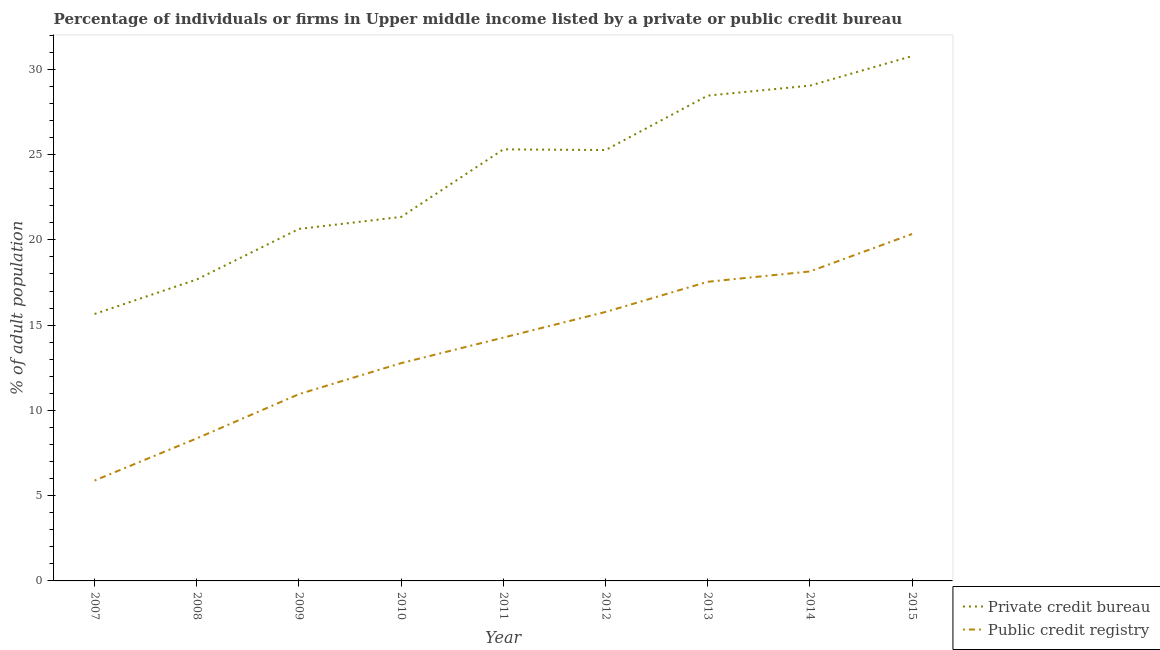Does the line corresponding to percentage of firms listed by public credit bureau intersect with the line corresponding to percentage of firms listed by private credit bureau?
Provide a short and direct response. No. Is the number of lines equal to the number of legend labels?
Offer a very short reply. Yes. What is the percentage of firms listed by private credit bureau in 2007?
Keep it short and to the point. 15.65. Across all years, what is the maximum percentage of firms listed by private credit bureau?
Keep it short and to the point. 30.78. Across all years, what is the minimum percentage of firms listed by private credit bureau?
Offer a terse response. 15.65. In which year was the percentage of firms listed by private credit bureau maximum?
Provide a short and direct response. 2015. What is the total percentage of firms listed by public credit bureau in the graph?
Give a very brief answer. 124.04. What is the difference between the percentage of firms listed by private credit bureau in 2007 and that in 2015?
Provide a short and direct response. -15.12. What is the difference between the percentage of firms listed by public credit bureau in 2012 and the percentage of firms listed by private credit bureau in 2013?
Your answer should be compact. -12.69. What is the average percentage of firms listed by public credit bureau per year?
Give a very brief answer. 13.78. In the year 2007, what is the difference between the percentage of firms listed by private credit bureau and percentage of firms listed by public credit bureau?
Keep it short and to the point. 9.77. In how many years, is the percentage of firms listed by private credit bureau greater than 3 %?
Make the answer very short. 9. What is the ratio of the percentage of firms listed by public credit bureau in 2010 to that in 2013?
Offer a very short reply. 0.73. Is the percentage of firms listed by public credit bureau in 2008 less than that in 2014?
Ensure brevity in your answer.  Yes. What is the difference between the highest and the second highest percentage of firms listed by private credit bureau?
Your response must be concise. 1.73. What is the difference between the highest and the lowest percentage of firms listed by public credit bureau?
Provide a succinct answer. 14.46. Does the percentage of firms listed by private credit bureau monotonically increase over the years?
Provide a succinct answer. No. Is the percentage of firms listed by private credit bureau strictly greater than the percentage of firms listed by public credit bureau over the years?
Your response must be concise. Yes. Is the percentage of firms listed by public credit bureau strictly less than the percentage of firms listed by private credit bureau over the years?
Ensure brevity in your answer.  Yes. How many lines are there?
Your answer should be compact. 2. What is the difference between two consecutive major ticks on the Y-axis?
Offer a terse response. 5. Does the graph contain grids?
Keep it short and to the point. No. How are the legend labels stacked?
Keep it short and to the point. Vertical. What is the title of the graph?
Your answer should be very brief. Percentage of individuals or firms in Upper middle income listed by a private or public credit bureau. Does "Lower secondary education" appear as one of the legend labels in the graph?
Your answer should be compact. No. What is the label or title of the X-axis?
Provide a succinct answer. Year. What is the label or title of the Y-axis?
Ensure brevity in your answer.  % of adult population. What is the % of adult population in Private credit bureau in 2007?
Your answer should be very brief. 15.65. What is the % of adult population of Public credit registry in 2007?
Make the answer very short. 5.89. What is the % of adult population in Private credit bureau in 2008?
Give a very brief answer. 17.68. What is the % of adult population in Public credit registry in 2008?
Offer a very short reply. 8.36. What is the % of adult population of Private credit bureau in 2009?
Keep it short and to the point. 20.64. What is the % of adult population of Public credit registry in 2009?
Give a very brief answer. 10.95. What is the % of adult population in Private credit bureau in 2010?
Make the answer very short. 21.34. What is the % of adult population in Public credit registry in 2010?
Your answer should be compact. 12.77. What is the % of adult population of Private credit bureau in 2011?
Give a very brief answer. 25.31. What is the % of adult population in Public credit registry in 2011?
Ensure brevity in your answer.  14.27. What is the % of adult population of Private credit bureau in 2012?
Offer a very short reply. 25.27. What is the % of adult population in Public credit registry in 2012?
Your response must be concise. 15.77. What is the % of adult population in Private credit bureau in 2013?
Make the answer very short. 28.46. What is the % of adult population of Public credit registry in 2013?
Give a very brief answer. 17.54. What is the % of adult population of Private credit bureau in 2014?
Make the answer very short. 29.04. What is the % of adult population in Public credit registry in 2014?
Provide a short and direct response. 18.15. What is the % of adult population of Private credit bureau in 2015?
Your response must be concise. 30.78. What is the % of adult population in Public credit registry in 2015?
Provide a short and direct response. 20.34. Across all years, what is the maximum % of adult population of Private credit bureau?
Provide a short and direct response. 30.78. Across all years, what is the maximum % of adult population in Public credit registry?
Keep it short and to the point. 20.34. Across all years, what is the minimum % of adult population in Private credit bureau?
Provide a short and direct response. 15.65. Across all years, what is the minimum % of adult population of Public credit registry?
Make the answer very short. 5.89. What is the total % of adult population of Private credit bureau in the graph?
Provide a succinct answer. 214.16. What is the total % of adult population of Public credit registry in the graph?
Offer a very short reply. 124.04. What is the difference between the % of adult population in Private credit bureau in 2007 and that in 2008?
Your response must be concise. -2.02. What is the difference between the % of adult population in Public credit registry in 2007 and that in 2008?
Provide a short and direct response. -2.47. What is the difference between the % of adult population of Private credit bureau in 2007 and that in 2009?
Offer a very short reply. -4.99. What is the difference between the % of adult population in Public credit registry in 2007 and that in 2009?
Your answer should be very brief. -5.07. What is the difference between the % of adult population of Private credit bureau in 2007 and that in 2010?
Provide a short and direct response. -5.69. What is the difference between the % of adult population of Public credit registry in 2007 and that in 2010?
Provide a short and direct response. -6.88. What is the difference between the % of adult population in Private credit bureau in 2007 and that in 2011?
Provide a short and direct response. -9.65. What is the difference between the % of adult population of Public credit registry in 2007 and that in 2011?
Keep it short and to the point. -8.38. What is the difference between the % of adult population in Private credit bureau in 2007 and that in 2012?
Keep it short and to the point. -9.61. What is the difference between the % of adult population in Public credit registry in 2007 and that in 2012?
Keep it short and to the point. -9.89. What is the difference between the % of adult population in Private credit bureau in 2007 and that in 2013?
Ensure brevity in your answer.  -12.81. What is the difference between the % of adult population of Public credit registry in 2007 and that in 2013?
Provide a succinct answer. -11.65. What is the difference between the % of adult population of Private credit bureau in 2007 and that in 2014?
Keep it short and to the point. -13.39. What is the difference between the % of adult population of Public credit registry in 2007 and that in 2014?
Offer a very short reply. -12.26. What is the difference between the % of adult population in Private credit bureau in 2007 and that in 2015?
Give a very brief answer. -15.12. What is the difference between the % of adult population of Public credit registry in 2007 and that in 2015?
Your answer should be compact. -14.46. What is the difference between the % of adult population of Private credit bureau in 2008 and that in 2009?
Make the answer very short. -2.96. What is the difference between the % of adult population in Public credit registry in 2008 and that in 2009?
Provide a succinct answer. -2.59. What is the difference between the % of adult population in Private credit bureau in 2008 and that in 2010?
Provide a short and direct response. -3.67. What is the difference between the % of adult population in Public credit registry in 2008 and that in 2010?
Give a very brief answer. -4.41. What is the difference between the % of adult population of Private credit bureau in 2008 and that in 2011?
Your response must be concise. -7.63. What is the difference between the % of adult population in Public credit registry in 2008 and that in 2011?
Your answer should be very brief. -5.91. What is the difference between the % of adult population in Private credit bureau in 2008 and that in 2012?
Make the answer very short. -7.59. What is the difference between the % of adult population in Public credit registry in 2008 and that in 2012?
Keep it short and to the point. -7.41. What is the difference between the % of adult population in Private credit bureau in 2008 and that in 2013?
Give a very brief answer. -10.78. What is the difference between the % of adult population of Public credit registry in 2008 and that in 2013?
Ensure brevity in your answer.  -9.18. What is the difference between the % of adult population in Private credit bureau in 2008 and that in 2014?
Give a very brief answer. -11.37. What is the difference between the % of adult population of Public credit registry in 2008 and that in 2014?
Make the answer very short. -9.79. What is the difference between the % of adult population of Private credit bureau in 2008 and that in 2015?
Provide a succinct answer. -13.1. What is the difference between the % of adult population of Public credit registry in 2008 and that in 2015?
Make the answer very short. -11.98. What is the difference between the % of adult population in Private credit bureau in 2009 and that in 2010?
Provide a short and direct response. -0.7. What is the difference between the % of adult population in Public credit registry in 2009 and that in 2010?
Ensure brevity in your answer.  -1.82. What is the difference between the % of adult population in Private credit bureau in 2009 and that in 2011?
Offer a terse response. -4.67. What is the difference between the % of adult population of Public credit registry in 2009 and that in 2011?
Make the answer very short. -3.32. What is the difference between the % of adult population of Private credit bureau in 2009 and that in 2012?
Offer a terse response. -4.63. What is the difference between the % of adult population of Public credit registry in 2009 and that in 2012?
Provide a succinct answer. -4.82. What is the difference between the % of adult population of Private credit bureau in 2009 and that in 2013?
Make the answer very short. -7.82. What is the difference between the % of adult population in Public credit registry in 2009 and that in 2013?
Offer a very short reply. -6.59. What is the difference between the % of adult population in Private credit bureau in 2009 and that in 2014?
Keep it short and to the point. -8.4. What is the difference between the % of adult population in Public credit registry in 2009 and that in 2014?
Provide a succinct answer. -7.19. What is the difference between the % of adult population in Private credit bureau in 2009 and that in 2015?
Provide a succinct answer. -10.14. What is the difference between the % of adult population of Public credit registry in 2009 and that in 2015?
Provide a short and direct response. -9.39. What is the difference between the % of adult population of Private credit bureau in 2010 and that in 2011?
Provide a succinct answer. -3.96. What is the difference between the % of adult population in Public credit registry in 2010 and that in 2011?
Keep it short and to the point. -1.5. What is the difference between the % of adult population in Private credit bureau in 2010 and that in 2012?
Make the answer very short. -3.92. What is the difference between the % of adult population of Public credit registry in 2010 and that in 2012?
Keep it short and to the point. -3. What is the difference between the % of adult population of Private credit bureau in 2010 and that in 2013?
Give a very brief answer. -7.11. What is the difference between the % of adult population of Public credit registry in 2010 and that in 2013?
Provide a succinct answer. -4.77. What is the difference between the % of adult population of Private credit bureau in 2010 and that in 2014?
Ensure brevity in your answer.  -7.7. What is the difference between the % of adult population of Public credit registry in 2010 and that in 2014?
Your response must be concise. -5.38. What is the difference between the % of adult population of Private credit bureau in 2010 and that in 2015?
Your response must be concise. -9.43. What is the difference between the % of adult population in Public credit registry in 2010 and that in 2015?
Offer a very short reply. -7.57. What is the difference between the % of adult population in Private credit bureau in 2011 and that in 2012?
Give a very brief answer. 0.04. What is the difference between the % of adult population in Public credit registry in 2011 and that in 2012?
Provide a short and direct response. -1.5. What is the difference between the % of adult population of Private credit bureau in 2011 and that in 2013?
Provide a succinct answer. -3.15. What is the difference between the % of adult population in Public credit registry in 2011 and that in 2013?
Your answer should be compact. -3.27. What is the difference between the % of adult population of Private credit bureau in 2011 and that in 2014?
Ensure brevity in your answer.  -3.74. What is the difference between the % of adult population of Public credit registry in 2011 and that in 2014?
Make the answer very short. -3.88. What is the difference between the % of adult population in Private credit bureau in 2011 and that in 2015?
Provide a short and direct response. -5.47. What is the difference between the % of adult population in Public credit registry in 2011 and that in 2015?
Offer a very short reply. -6.07. What is the difference between the % of adult population in Private credit bureau in 2012 and that in 2013?
Offer a terse response. -3.19. What is the difference between the % of adult population of Public credit registry in 2012 and that in 2013?
Ensure brevity in your answer.  -1.77. What is the difference between the % of adult population in Private credit bureau in 2012 and that in 2014?
Your answer should be very brief. -3.78. What is the difference between the % of adult population of Public credit registry in 2012 and that in 2014?
Offer a very short reply. -2.38. What is the difference between the % of adult population in Private credit bureau in 2012 and that in 2015?
Ensure brevity in your answer.  -5.51. What is the difference between the % of adult population of Public credit registry in 2012 and that in 2015?
Your answer should be compact. -4.57. What is the difference between the % of adult population in Private credit bureau in 2013 and that in 2014?
Offer a very short reply. -0.58. What is the difference between the % of adult population in Public credit registry in 2013 and that in 2014?
Your response must be concise. -0.61. What is the difference between the % of adult population in Private credit bureau in 2013 and that in 2015?
Give a very brief answer. -2.32. What is the difference between the % of adult population of Public credit registry in 2013 and that in 2015?
Give a very brief answer. -2.8. What is the difference between the % of adult population in Private credit bureau in 2014 and that in 2015?
Give a very brief answer. -1.73. What is the difference between the % of adult population of Public credit registry in 2014 and that in 2015?
Provide a short and direct response. -2.2. What is the difference between the % of adult population in Private credit bureau in 2007 and the % of adult population in Public credit registry in 2008?
Offer a very short reply. 7.29. What is the difference between the % of adult population in Private credit bureau in 2007 and the % of adult population in Public credit registry in 2010?
Your response must be concise. 2.88. What is the difference between the % of adult population in Private credit bureau in 2007 and the % of adult population in Public credit registry in 2011?
Your answer should be compact. 1.38. What is the difference between the % of adult population in Private credit bureau in 2007 and the % of adult population in Public credit registry in 2012?
Give a very brief answer. -0.12. What is the difference between the % of adult population of Private credit bureau in 2007 and the % of adult population of Public credit registry in 2013?
Make the answer very short. -1.89. What is the difference between the % of adult population in Private credit bureau in 2007 and the % of adult population in Public credit registry in 2014?
Make the answer very short. -2.49. What is the difference between the % of adult population of Private credit bureau in 2007 and the % of adult population of Public credit registry in 2015?
Your answer should be compact. -4.69. What is the difference between the % of adult population in Private credit bureau in 2008 and the % of adult population in Public credit registry in 2009?
Keep it short and to the point. 6.72. What is the difference between the % of adult population in Private credit bureau in 2008 and the % of adult population in Public credit registry in 2010?
Your answer should be compact. 4.91. What is the difference between the % of adult population in Private credit bureau in 2008 and the % of adult population in Public credit registry in 2011?
Offer a very short reply. 3.41. What is the difference between the % of adult population in Private credit bureau in 2008 and the % of adult population in Public credit registry in 2012?
Provide a short and direct response. 1.91. What is the difference between the % of adult population of Private credit bureau in 2008 and the % of adult population of Public credit registry in 2013?
Your answer should be very brief. 0.14. What is the difference between the % of adult population in Private credit bureau in 2008 and the % of adult population in Public credit registry in 2014?
Keep it short and to the point. -0.47. What is the difference between the % of adult population in Private credit bureau in 2008 and the % of adult population in Public credit registry in 2015?
Your answer should be very brief. -2.67. What is the difference between the % of adult population of Private credit bureau in 2009 and the % of adult population of Public credit registry in 2010?
Your answer should be very brief. 7.87. What is the difference between the % of adult population in Private credit bureau in 2009 and the % of adult population in Public credit registry in 2011?
Offer a very short reply. 6.37. What is the difference between the % of adult population of Private credit bureau in 2009 and the % of adult population of Public credit registry in 2012?
Offer a very short reply. 4.87. What is the difference between the % of adult population of Private credit bureau in 2009 and the % of adult population of Public credit registry in 2013?
Offer a very short reply. 3.1. What is the difference between the % of adult population in Private credit bureau in 2009 and the % of adult population in Public credit registry in 2014?
Provide a succinct answer. 2.49. What is the difference between the % of adult population in Private credit bureau in 2009 and the % of adult population in Public credit registry in 2015?
Your answer should be compact. 0.3. What is the difference between the % of adult population of Private credit bureau in 2010 and the % of adult population of Public credit registry in 2011?
Your answer should be very brief. 7.08. What is the difference between the % of adult population in Private credit bureau in 2010 and the % of adult population in Public credit registry in 2012?
Ensure brevity in your answer.  5.57. What is the difference between the % of adult population of Private credit bureau in 2010 and the % of adult population of Public credit registry in 2013?
Your answer should be very brief. 3.8. What is the difference between the % of adult population of Private credit bureau in 2010 and the % of adult population of Public credit registry in 2014?
Ensure brevity in your answer.  3.2. What is the difference between the % of adult population in Private credit bureau in 2010 and the % of adult population in Public credit registry in 2015?
Your answer should be compact. 1. What is the difference between the % of adult population of Private credit bureau in 2011 and the % of adult population of Public credit registry in 2012?
Your answer should be very brief. 9.53. What is the difference between the % of adult population in Private credit bureau in 2011 and the % of adult population in Public credit registry in 2013?
Make the answer very short. 7.77. What is the difference between the % of adult population in Private credit bureau in 2011 and the % of adult population in Public credit registry in 2014?
Give a very brief answer. 7.16. What is the difference between the % of adult population of Private credit bureau in 2011 and the % of adult population of Public credit registry in 2015?
Keep it short and to the point. 4.96. What is the difference between the % of adult population of Private credit bureau in 2012 and the % of adult population of Public credit registry in 2013?
Give a very brief answer. 7.72. What is the difference between the % of adult population in Private credit bureau in 2012 and the % of adult population in Public credit registry in 2014?
Ensure brevity in your answer.  7.12. What is the difference between the % of adult population in Private credit bureau in 2012 and the % of adult population in Public credit registry in 2015?
Provide a short and direct response. 4.92. What is the difference between the % of adult population in Private credit bureau in 2013 and the % of adult population in Public credit registry in 2014?
Give a very brief answer. 10.31. What is the difference between the % of adult population in Private credit bureau in 2013 and the % of adult population in Public credit registry in 2015?
Your answer should be compact. 8.12. What is the average % of adult population of Private credit bureau per year?
Keep it short and to the point. 23.8. What is the average % of adult population in Public credit registry per year?
Provide a short and direct response. 13.78. In the year 2007, what is the difference between the % of adult population in Private credit bureau and % of adult population in Public credit registry?
Ensure brevity in your answer.  9.77. In the year 2008, what is the difference between the % of adult population of Private credit bureau and % of adult population of Public credit registry?
Ensure brevity in your answer.  9.32. In the year 2009, what is the difference between the % of adult population in Private credit bureau and % of adult population in Public credit registry?
Offer a very short reply. 9.69. In the year 2010, what is the difference between the % of adult population in Private credit bureau and % of adult population in Public credit registry?
Keep it short and to the point. 8.57. In the year 2011, what is the difference between the % of adult population in Private credit bureau and % of adult population in Public credit registry?
Your answer should be compact. 11.04. In the year 2012, what is the difference between the % of adult population of Private credit bureau and % of adult population of Public credit registry?
Your answer should be very brief. 9.49. In the year 2013, what is the difference between the % of adult population in Private credit bureau and % of adult population in Public credit registry?
Provide a succinct answer. 10.92. In the year 2014, what is the difference between the % of adult population in Private credit bureau and % of adult population in Public credit registry?
Your answer should be compact. 10.9. In the year 2015, what is the difference between the % of adult population in Private credit bureau and % of adult population in Public credit registry?
Your response must be concise. 10.43. What is the ratio of the % of adult population in Private credit bureau in 2007 to that in 2008?
Offer a very short reply. 0.89. What is the ratio of the % of adult population in Public credit registry in 2007 to that in 2008?
Offer a very short reply. 0.7. What is the ratio of the % of adult population of Private credit bureau in 2007 to that in 2009?
Give a very brief answer. 0.76. What is the ratio of the % of adult population of Public credit registry in 2007 to that in 2009?
Your answer should be very brief. 0.54. What is the ratio of the % of adult population of Private credit bureau in 2007 to that in 2010?
Offer a very short reply. 0.73. What is the ratio of the % of adult population of Public credit registry in 2007 to that in 2010?
Offer a very short reply. 0.46. What is the ratio of the % of adult population of Private credit bureau in 2007 to that in 2011?
Ensure brevity in your answer.  0.62. What is the ratio of the % of adult population of Public credit registry in 2007 to that in 2011?
Your answer should be compact. 0.41. What is the ratio of the % of adult population of Private credit bureau in 2007 to that in 2012?
Make the answer very short. 0.62. What is the ratio of the % of adult population in Public credit registry in 2007 to that in 2012?
Keep it short and to the point. 0.37. What is the ratio of the % of adult population of Private credit bureau in 2007 to that in 2013?
Your answer should be compact. 0.55. What is the ratio of the % of adult population in Public credit registry in 2007 to that in 2013?
Ensure brevity in your answer.  0.34. What is the ratio of the % of adult population of Private credit bureau in 2007 to that in 2014?
Give a very brief answer. 0.54. What is the ratio of the % of adult population of Public credit registry in 2007 to that in 2014?
Make the answer very short. 0.32. What is the ratio of the % of adult population of Private credit bureau in 2007 to that in 2015?
Provide a succinct answer. 0.51. What is the ratio of the % of adult population of Public credit registry in 2007 to that in 2015?
Give a very brief answer. 0.29. What is the ratio of the % of adult population in Private credit bureau in 2008 to that in 2009?
Your response must be concise. 0.86. What is the ratio of the % of adult population of Public credit registry in 2008 to that in 2009?
Keep it short and to the point. 0.76. What is the ratio of the % of adult population of Private credit bureau in 2008 to that in 2010?
Your answer should be very brief. 0.83. What is the ratio of the % of adult population in Public credit registry in 2008 to that in 2010?
Ensure brevity in your answer.  0.65. What is the ratio of the % of adult population of Private credit bureau in 2008 to that in 2011?
Ensure brevity in your answer.  0.7. What is the ratio of the % of adult population of Public credit registry in 2008 to that in 2011?
Provide a succinct answer. 0.59. What is the ratio of the % of adult population of Private credit bureau in 2008 to that in 2012?
Keep it short and to the point. 0.7. What is the ratio of the % of adult population of Public credit registry in 2008 to that in 2012?
Your response must be concise. 0.53. What is the ratio of the % of adult population in Private credit bureau in 2008 to that in 2013?
Ensure brevity in your answer.  0.62. What is the ratio of the % of adult population of Public credit registry in 2008 to that in 2013?
Give a very brief answer. 0.48. What is the ratio of the % of adult population of Private credit bureau in 2008 to that in 2014?
Your response must be concise. 0.61. What is the ratio of the % of adult population in Public credit registry in 2008 to that in 2014?
Provide a succinct answer. 0.46. What is the ratio of the % of adult population in Private credit bureau in 2008 to that in 2015?
Your answer should be very brief. 0.57. What is the ratio of the % of adult population in Public credit registry in 2008 to that in 2015?
Ensure brevity in your answer.  0.41. What is the ratio of the % of adult population in Public credit registry in 2009 to that in 2010?
Your response must be concise. 0.86. What is the ratio of the % of adult population of Private credit bureau in 2009 to that in 2011?
Make the answer very short. 0.82. What is the ratio of the % of adult population in Public credit registry in 2009 to that in 2011?
Provide a succinct answer. 0.77. What is the ratio of the % of adult population in Private credit bureau in 2009 to that in 2012?
Keep it short and to the point. 0.82. What is the ratio of the % of adult population of Public credit registry in 2009 to that in 2012?
Ensure brevity in your answer.  0.69. What is the ratio of the % of adult population of Private credit bureau in 2009 to that in 2013?
Offer a terse response. 0.73. What is the ratio of the % of adult population of Public credit registry in 2009 to that in 2013?
Ensure brevity in your answer.  0.62. What is the ratio of the % of adult population of Private credit bureau in 2009 to that in 2014?
Provide a succinct answer. 0.71. What is the ratio of the % of adult population in Public credit registry in 2009 to that in 2014?
Offer a terse response. 0.6. What is the ratio of the % of adult population in Private credit bureau in 2009 to that in 2015?
Give a very brief answer. 0.67. What is the ratio of the % of adult population in Public credit registry in 2009 to that in 2015?
Your answer should be very brief. 0.54. What is the ratio of the % of adult population in Private credit bureau in 2010 to that in 2011?
Offer a terse response. 0.84. What is the ratio of the % of adult population in Public credit registry in 2010 to that in 2011?
Make the answer very short. 0.9. What is the ratio of the % of adult population of Private credit bureau in 2010 to that in 2012?
Ensure brevity in your answer.  0.84. What is the ratio of the % of adult population in Public credit registry in 2010 to that in 2012?
Your response must be concise. 0.81. What is the ratio of the % of adult population of Private credit bureau in 2010 to that in 2013?
Offer a terse response. 0.75. What is the ratio of the % of adult population in Public credit registry in 2010 to that in 2013?
Your response must be concise. 0.73. What is the ratio of the % of adult population in Private credit bureau in 2010 to that in 2014?
Make the answer very short. 0.73. What is the ratio of the % of adult population in Public credit registry in 2010 to that in 2014?
Offer a very short reply. 0.7. What is the ratio of the % of adult population of Private credit bureau in 2010 to that in 2015?
Your answer should be compact. 0.69. What is the ratio of the % of adult population of Public credit registry in 2010 to that in 2015?
Offer a terse response. 0.63. What is the ratio of the % of adult population in Public credit registry in 2011 to that in 2012?
Keep it short and to the point. 0.9. What is the ratio of the % of adult population of Private credit bureau in 2011 to that in 2013?
Ensure brevity in your answer.  0.89. What is the ratio of the % of adult population of Public credit registry in 2011 to that in 2013?
Provide a succinct answer. 0.81. What is the ratio of the % of adult population of Private credit bureau in 2011 to that in 2014?
Your answer should be very brief. 0.87. What is the ratio of the % of adult population in Public credit registry in 2011 to that in 2014?
Your answer should be very brief. 0.79. What is the ratio of the % of adult population of Private credit bureau in 2011 to that in 2015?
Provide a short and direct response. 0.82. What is the ratio of the % of adult population in Public credit registry in 2011 to that in 2015?
Your response must be concise. 0.7. What is the ratio of the % of adult population in Private credit bureau in 2012 to that in 2013?
Keep it short and to the point. 0.89. What is the ratio of the % of adult population in Public credit registry in 2012 to that in 2013?
Offer a very short reply. 0.9. What is the ratio of the % of adult population in Private credit bureau in 2012 to that in 2014?
Your answer should be very brief. 0.87. What is the ratio of the % of adult population of Public credit registry in 2012 to that in 2014?
Provide a short and direct response. 0.87. What is the ratio of the % of adult population in Private credit bureau in 2012 to that in 2015?
Ensure brevity in your answer.  0.82. What is the ratio of the % of adult population in Public credit registry in 2012 to that in 2015?
Provide a succinct answer. 0.78. What is the ratio of the % of adult population in Private credit bureau in 2013 to that in 2014?
Offer a very short reply. 0.98. What is the ratio of the % of adult population in Public credit registry in 2013 to that in 2014?
Provide a short and direct response. 0.97. What is the ratio of the % of adult population of Private credit bureau in 2013 to that in 2015?
Your answer should be very brief. 0.92. What is the ratio of the % of adult population in Public credit registry in 2013 to that in 2015?
Offer a terse response. 0.86. What is the ratio of the % of adult population of Private credit bureau in 2014 to that in 2015?
Offer a terse response. 0.94. What is the ratio of the % of adult population of Public credit registry in 2014 to that in 2015?
Your answer should be very brief. 0.89. What is the difference between the highest and the second highest % of adult population of Private credit bureau?
Your response must be concise. 1.73. What is the difference between the highest and the second highest % of adult population in Public credit registry?
Ensure brevity in your answer.  2.2. What is the difference between the highest and the lowest % of adult population of Private credit bureau?
Provide a succinct answer. 15.12. What is the difference between the highest and the lowest % of adult population in Public credit registry?
Your answer should be very brief. 14.46. 